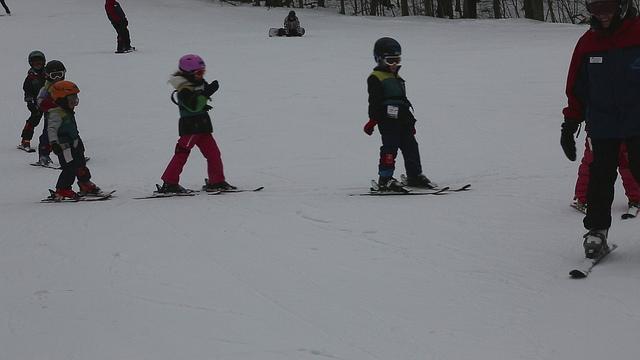What sort of lesson might the short people be getting?
Pick the correct solution from the four options below to address the question.
Options: Beginner ski, olympic ski, marshmallows, kittens. Beginner ski. 